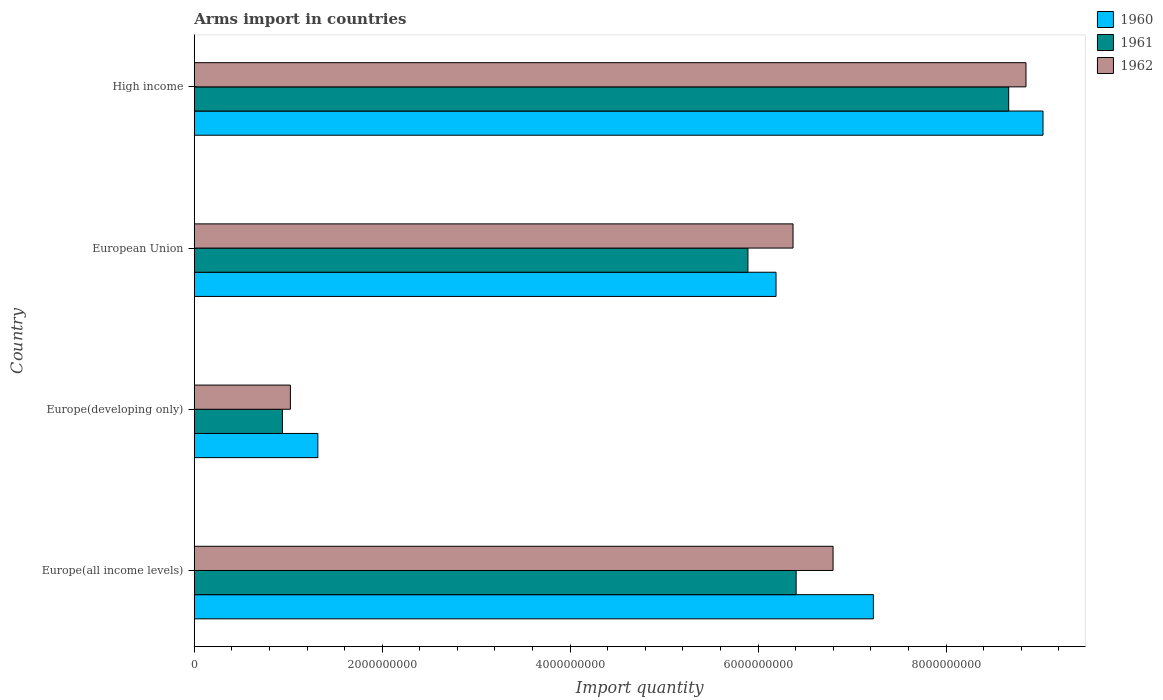How many different coloured bars are there?
Your answer should be compact. 3. Are the number of bars per tick equal to the number of legend labels?
Your answer should be compact. Yes. Are the number of bars on each tick of the Y-axis equal?
Provide a succinct answer. Yes. What is the label of the 3rd group of bars from the top?
Offer a terse response. Europe(developing only). In how many cases, is the number of bars for a given country not equal to the number of legend labels?
Offer a very short reply. 0. What is the total arms import in 1960 in Europe(developing only)?
Offer a terse response. 1.32e+09. Across all countries, what is the maximum total arms import in 1962?
Make the answer very short. 8.85e+09. Across all countries, what is the minimum total arms import in 1961?
Ensure brevity in your answer.  9.38e+08. In which country was the total arms import in 1960 maximum?
Offer a terse response. High income. In which country was the total arms import in 1962 minimum?
Give a very brief answer. Europe(developing only). What is the total total arms import in 1960 in the graph?
Give a very brief answer. 2.38e+1. What is the difference between the total arms import in 1960 in Europe(developing only) and that in High income?
Your answer should be compact. -7.72e+09. What is the difference between the total arms import in 1962 in Europe(all income levels) and the total arms import in 1961 in Europe(developing only)?
Provide a succinct answer. 5.86e+09. What is the average total arms import in 1960 per country?
Offer a terse response. 5.94e+09. What is the difference between the total arms import in 1961 and total arms import in 1960 in Europe(all income levels)?
Offer a terse response. -8.22e+08. What is the ratio of the total arms import in 1962 in Europe(developing only) to that in European Union?
Offer a terse response. 0.16. Is the difference between the total arms import in 1961 in Europe(developing only) and European Union greater than the difference between the total arms import in 1960 in Europe(developing only) and European Union?
Provide a short and direct response. No. What is the difference between the highest and the second highest total arms import in 1961?
Keep it short and to the point. 2.26e+09. What is the difference between the highest and the lowest total arms import in 1960?
Provide a short and direct response. 7.72e+09. In how many countries, is the total arms import in 1961 greater than the average total arms import in 1961 taken over all countries?
Offer a terse response. 3. What does the 1st bar from the top in High income represents?
Make the answer very short. 1962. What does the 3rd bar from the bottom in High income represents?
Your answer should be very brief. 1962. Is it the case that in every country, the sum of the total arms import in 1960 and total arms import in 1961 is greater than the total arms import in 1962?
Give a very brief answer. Yes. How many bars are there?
Provide a short and direct response. 12. Are all the bars in the graph horizontal?
Offer a very short reply. Yes. How many countries are there in the graph?
Your response must be concise. 4. Does the graph contain grids?
Offer a terse response. No. Where does the legend appear in the graph?
Provide a succinct answer. Top right. How are the legend labels stacked?
Keep it short and to the point. Vertical. What is the title of the graph?
Your answer should be very brief. Arms import in countries. What is the label or title of the X-axis?
Your answer should be very brief. Import quantity. What is the Import quantity of 1960 in Europe(all income levels)?
Offer a very short reply. 7.23e+09. What is the Import quantity in 1961 in Europe(all income levels)?
Your response must be concise. 6.40e+09. What is the Import quantity in 1962 in Europe(all income levels)?
Provide a succinct answer. 6.80e+09. What is the Import quantity in 1960 in Europe(developing only)?
Offer a terse response. 1.32e+09. What is the Import quantity in 1961 in Europe(developing only)?
Provide a succinct answer. 9.38e+08. What is the Import quantity of 1962 in Europe(developing only)?
Ensure brevity in your answer.  1.02e+09. What is the Import quantity in 1960 in European Union?
Your answer should be very brief. 6.19e+09. What is the Import quantity in 1961 in European Union?
Provide a succinct answer. 5.89e+09. What is the Import quantity in 1962 in European Union?
Provide a succinct answer. 6.37e+09. What is the Import quantity in 1960 in High income?
Give a very brief answer. 9.03e+09. What is the Import quantity in 1961 in High income?
Offer a terse response. 8.67e+09. What is the Import quantity of 1962 in High income?
Your response must be concise. 8.85e+09. Across all countries, what is the maximum Import quantity in 1960?
Keep it short and to the point. 9.03e+09. Across all countries, what is the maximum Import quantity in 1961?
Offer a terse response. 8.67e+09. Across all countries, what is the maximum Import quantity of 1962?
Offer a very short reply. 8.85e+09. Across all countries, what is the minimum Import quantity in 1960?
Keep it short and to the point. 1.32e+09. Across all countries, what is the minimum Import quantity in 1961?
Make the answer very short. 9.38e+08. Across all countries, what is the minimum Import quantity of 1962?
Offer a terse response. 1.02e+09. What is the total Import quantity in 1960 in the graph?
Offer a very short reply. 2.38e+1. What is the total Import quantity in 1961 in the graph?
Provide a succinct answer. 2.19e+1. What is the total Import quantity of 1962 in the graph?
Ensure brevity in your answer.  2.30e+1. What is the difference between the Import quantity of 1960 in Europe(all income levels) and that in Europe(developing only)?
Keep it short and to the point. 5.91e+09. What is the difference between the Import quantity in 1961 in Europe(all income levels) and that in Europe(developing only)?
Make the answer very short. 5.47e+09. What is the difference between the Import quantity in 1962 in Europe(all income levels) and that in Europe(developing only)?
Your answer should be compact. 5.78e+09. What is the difference between the Import quantity in 1960 in Europe(all income levels) and that in European Union?
Offer a terse response. 1.04e+09. What is the difference between the Import quantity of 1961 in Europe(all income levels) and that in European Union?
Ensure brevity in your answer.  5.13e+08. What is the difference between the Import quantity of 1962 in Europe(all income levels) and that in European Union?
Offer a very short reply. 4.26e+08. What is the difference between the Import quantity of 1960 in Europe(all income levels) and that in High income?
Offer a very short reply. -1.80e+09. What is the difference between the Import quantity in 1961 in Europe(all income levels) and that in High income?
Provide a succinct answer. -2.26e+09. What is the difference between the Import quantity of 1962 in Europe(all income levels) and that in High income?
Make the answer very short. -2.05e+09. What is the difference between the Import quantity of 1960 in Europe(developing only) and that in European Union?
Ensure brevity in your answer.  -4.88e+09. What is the difference between the Import quantity in 1961 in Europe(developing only) and that in European Union?
Provide a short and direct response. -4.95e+09. What is the difference between the Import quantity of 1962 in Europe(developing only) and that in European Union?
Keep it short and to the point. -5.35e+09. What is the difference between the Import quantity in 1960 in Europe(developing only) and that in High income?
Provide a succinct answer. -7.72e+09. What is the difference between the Import quantity in 1961 in Europe(developing only) and that in High income?
Keep it short and to the point. -7.73e+09. What is the difference between the Import quantity of 1962 in Europe(developing only) and that in High income?
Offer a very short reply. -7.83e+09. What is the difference between the Import quantity of 1960 in European Union and that in High income?
Offer a very short reply. -2.84e+09. What is the difference between the Import quantity in 1961 in European Union and that in High income?
Your response must be concise. -2.78e+09. What is the difference between the Import quantity of 1962 in European Union and that in High income?
Offer a very short reply. -2.48e+09. What is the difference between the Import quantity in 1960 in Europe(all income levels) and the Import quantity in 1961 in Europe(developing only)?
Give a very brief answer. 6.29e+09. What is the difference between the Import quantity of 1960 in Europe(all income levels) and the Import quantity of 1962 in Europe(developing only)?
Your response must be concise. 6.20e+09. What is the difference between the Import quantity of 1961 in Europe(all income levels) and the Import quantity of 1962 in Europe(developing only)?
Ensure brevity in your answer.  5.38e+09. What is the difference between the Import quantity of 1960 in Europe(all income levels) and the Import quantity of 1961 in European Union?
Keep it short and to the point. 1.34e+09. What is the difference between the Import quantity in 1960 in Europe(all income levels) and the Import quantity in 1962 in European Union?
Offer a very short reply. 8.55e+08. What is the difference between the Import quantity of 1961 in Europe(all income levels) and the Import quantity of 1962 in European Union?
Your answer should be very brief. 3.30e+07. What is the difference between the Import quantity of 1960 in Europe(all income levels) and the Import quantity of 1961 in High income?
Make the answer very short. -1.44e+09. What is the difference between the Import quantity of 1960 in Europe(all income levels) and the Import quantity of 1962 in High income?
Offer a terse response. -1.62e+09. What is the difference between the Import quantity in 1961 in Europe(all income levels) and the Import quantity in 1962 in High income?
Your answer should be compact. -2.45e+09. What is the difference between the Import quantity of 1960 in Europe(developing only) and the Import quantity of 1961 in European Union?
Make the answer very short. -4.58e+09. What is the difference between the Import quantity in 1960 in Europe(developing only) and the Import quantity in 1962 in European Union?
Keep it short and to the point. -5.06e+09. What is the difference between the Import quantity of 1961 in Europe(developing only) and the Import quantity of 1962 in European Union?
Make the answer very short. -5.43e+09. What is the difference between the Import quantity in 1960 in Europe(developing only) and the Import quantity in 1961 in High income?
Offer a very short reply. -7.35e+09. What is the difference between the Import quantity in 1960 in Europe(developing only) and the Import quantity in 1962 in High income?
Provide a succinct answer. -7.54e+09. What is the difference between the Import quantity of 1961 in Europe(developing only) and the Import quantity of 1962 in High income?
Your response must be concise. -7.91e+09. What is the difference between the Import quantity in 1960 in European Union and the Import quantity in 1961 in High income?
Make the answer very short. -2.48e+09. What is the difference between the Import quantity of 1960 in European Union and the Import quantity of 1962 in High income?
Your answer should be compact. -2.66e+09. What is the difference between the Import quantity of 1961 in European Union and the Import quantity of 1962 in High income?
Give a very brief answer. -2.96e+09. What is the average Import quantity of 1960 per country?
Offer a very short reply. 5.94e+09. What is the average Import quantity in 1961 per country?
Give a very brief answer. 5.48e+09. What is the average Import quantity in 1962 per country?
Your answer should be compact. 5.76e+09. What is the difference between the Import quantity of 1960 and Import quantity of 1961 in Europe(all income levels)?
Make the answer very short. 8.22e+08. What is the difference between the Import quantity of 1960 and Import quantity of 1962 in Europe(all income levels)?
Your response must be concise. 4.29e+08. What is the difference between the Import quantity in 1961 and Import quantity in 1962 in Europe(all income levels)?
Ensure brevity in your answer.  -3.93e+08. What is the difference between the Import quantity in 1960 and Import quantity in 1961 in Europe(developing only)?
Make the answer very short. 3.77e+08. What is the difference between the Import quantity of 1960 and Import quantity of 1962 in Europe(developing only)?
Provide a short and direct response. 2.92e+08. What is the difference between the Import quantity of 1961 and Import quantity of 1962 in Europe(developing only)?
Your answer should be very brief. -8.50e+07. What is the difference between the Import quantity of 1960 and Import quantity of 1961 in European Union?
Offer a terse response. 2.99e+08. What is the difference between the Import quantity of 1960 and Import quantity of 1962 in European Union?
Provide a short and direct response. -1.81e+08. What is the difference between the Import quantity in 1961 and Import quantity in 1962 in European Union?
Give a very brief answer. -4.80e+08. What is the difference between the Import quantity in 1960 and Import quantity in 1961 in High income?
Offer a very short reply. 3.65e+08. What is the difference between the Import quantity in 1960 and Import quantity in 1962 in High income?
Give a very brief answer. 1.81e+08. What is the difference between the Import quantity in 1961 and Import quantity in 1962 in High income?
Offer a very short reply. -1.84e+08. What is the ratio of the Import quantity of 1960 in Europe(all income levels) to that in Europe(developing only)?
Give a very brief answer. 5.5. What is the ratio of the Import quantity in 1961 in Europe(all income levels) to that in Europe(developing only)?
Keep it short and to the point. 6.83. What is the ratio of the Import quantity of 1962 in Europe(all income levels) to that in Europe(developing only)?
Keep it short and to the point. 6.65. What is the ratio of the Import quantity of 1960 in Europe(all income levels) to that in European Union?
Provide a short and direct response. 1.17. What is the ratio of the Import quantity in 1961 in Europe(all income levels) to that in European Union?
Provide a succinct answer. 1.09. What is the ratio of the Import quantity in 1962 in Europe(all income levels) to that in European Union?
Give a very brief answer. 1.07. What is the ratio of the Import quantity of 1960 in Europe(all income levels) to that in High income?
Your response must be concise. 0.8. What is the ratio of the Import quantity of 1961 in Europe(all income levels) to that in High income?
Your answer should be very brief. 0.74. What is the ratio of the Import quantity of 1962 in Europe(all income levels) to that in High income?
Ensure brevity in your answer.  0.77. What is the ratio of the Import quantity in 1960 in Europe(developing only) to that in European Union?
Make the answer very short. 0.21. What is the ratio of the Import quantity in 1961 in Europe(developing only) to that in European Union?
Your answer should be compact. 0.16. What is the ratio of the Import quantity in 1962 in Europe(developing only) to that in European Union?
Keep it short and to the point. 0.16. What is the ratio of the Import quantity in 1960 in Europe(developing only) to that in High income?
Offer a very short reply. 0.15. What is the ratio of the Import quantity of 1961 in Europe(developing only) to that in High income?
Your response must be concise. 0.11. What is the ratio of the Import quantity in 1962 in Europe(developing only) to that in High income?
Provide a succinct answer. 0.12. What is the ratio of the Import quantity in 1960 in European Union to that in High income?
Make the answer very short. 0.69. What is the ratio of the Import quantity in 1961 in European Union to that in High income?
Ensure brevity in your answer.  0.68. What is the ratio of the Import quantity of 1962 in European Union to that in High income?
Your answer should be compact. 0.72. What is the difference between the highest and the second highest Import quantity in 1960?
Your response must be concise. 1.80e+09. What is the difference between the highest and the second highest Import quantity of 1961?
Ensure brevity in your answer.  2.26e+09. What is the difference between the highest and the second highest Import quantity in 1962?
Give a very brief answer. 2.05e+09. What is the difference between the highest and the lowest Import quantity of 1960?
Your answer should be very brief. 7.72e+09. What is the difference between the highest and the lowest Import quantity of 1961?
Make the answer very short. 7.73e+09. What is the difference between the highest and the lowest Import quantity in 1962?
Offer a terse response. 7.83e+09. 